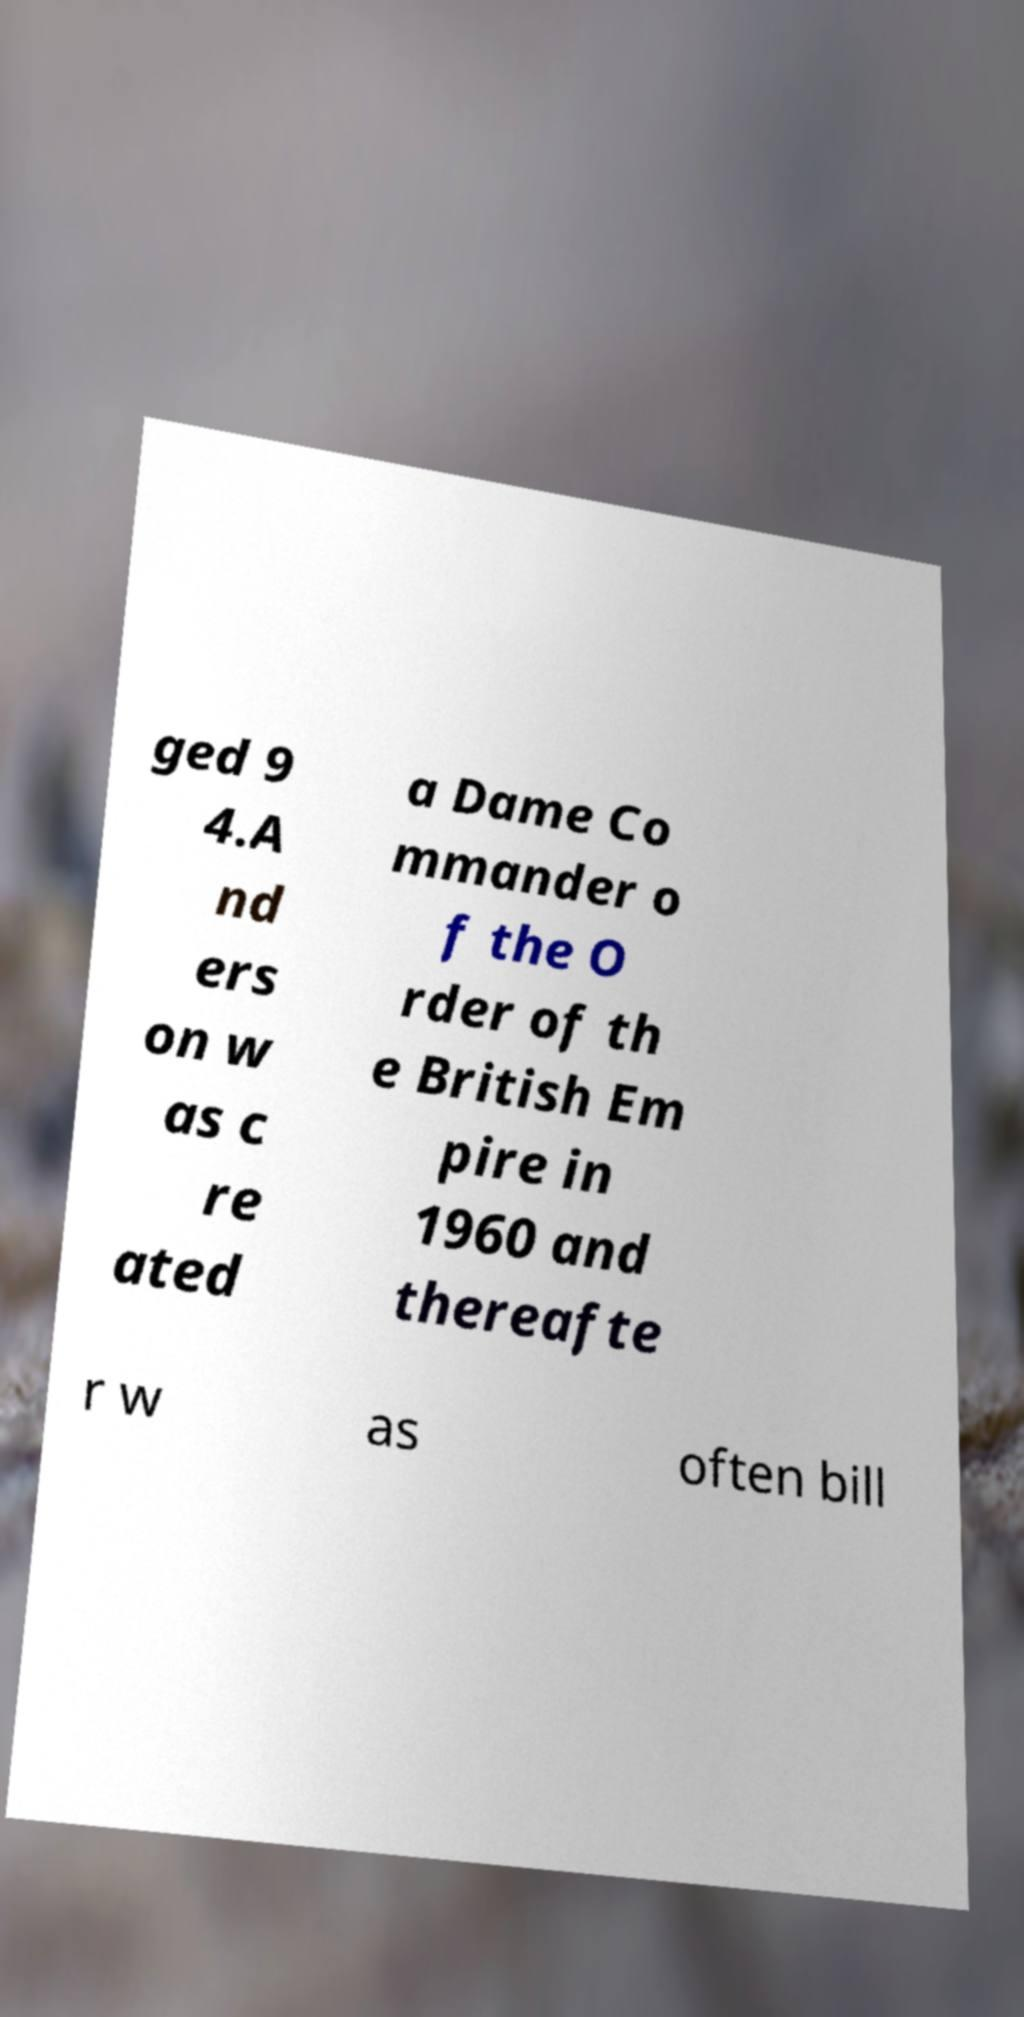For documentation purposes, I need the text within this image transcribed. Could you provide that? ged 9 4.A nd ers on w as c re ated a Dame Co mmander o f the O rder of th e British Em pire in 1960 and thereafte r w as often bill 